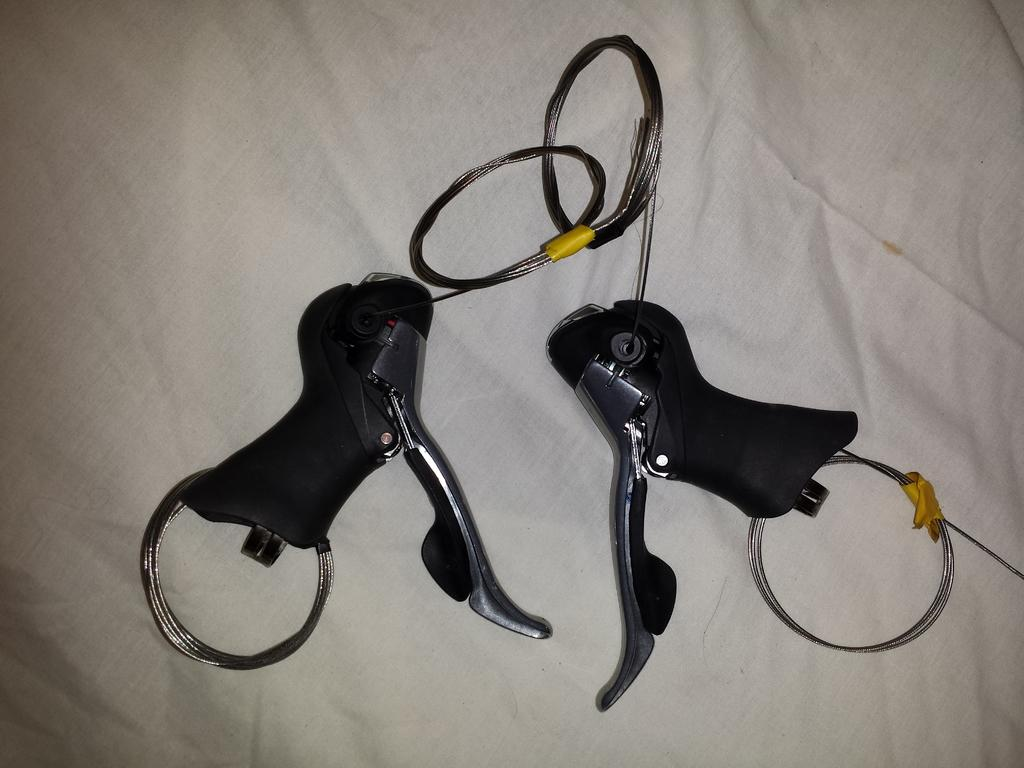What can be seen in the image? There are objects in the image. Can you describe the white cloth in the image? There is a white cloth at the bottom of the image. What type of vein is visible on the bushes in the image? There are no bushes or veins present in the image. What type of print can be seen on the objects in the image? We cannot determine the type of print on the objects in the image, as the facts do not provide any information about the objects' appearance or design. 